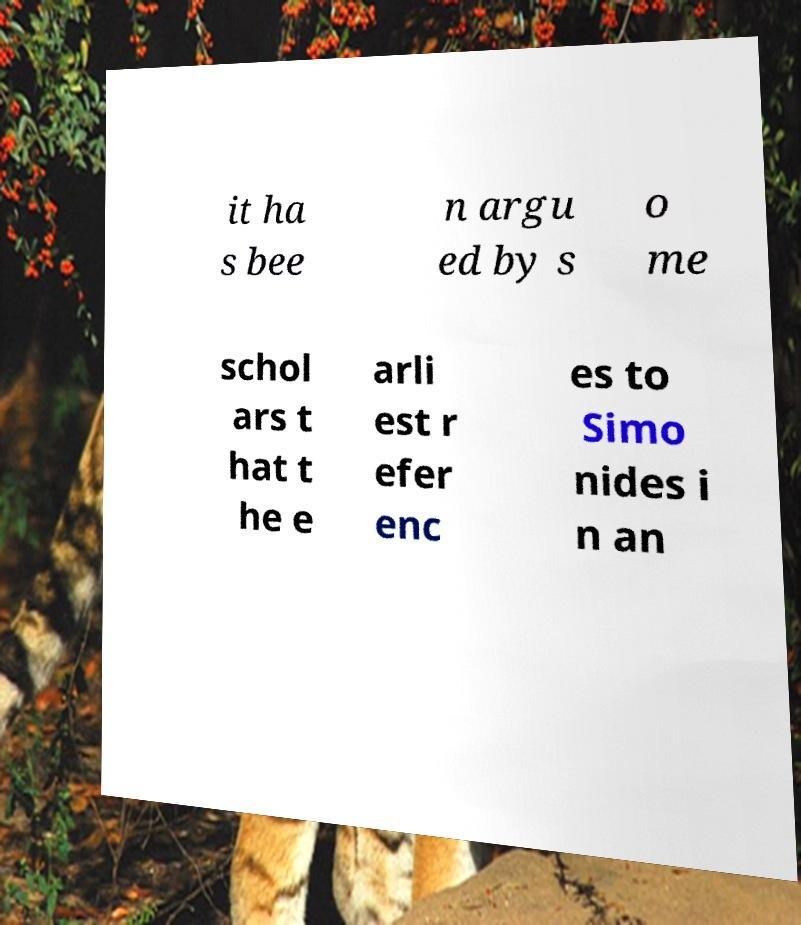Please read and relay the text visible in this image. What does it say? it ha s bee n argu ed by s o me schol ars t hat t he e arli est r efer enc es to Simo nides i n an 